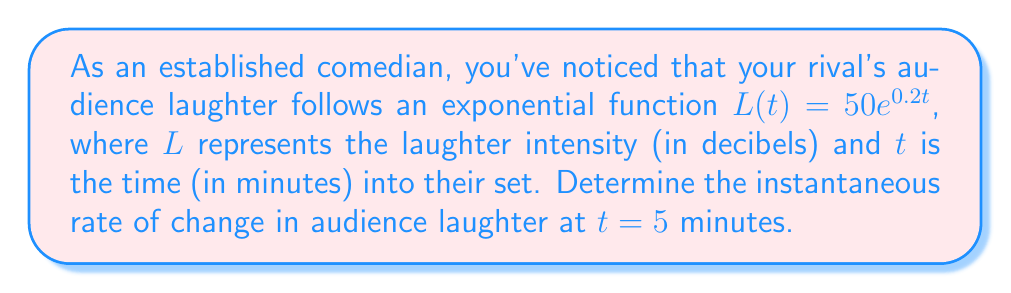Help me with this question. To find the instantaneous rate of change, we need to calculate the derivative of the given function and evaluate it at $t = 5$.

1) The given function is $L(t) = 50e^{0.2t}$

2) To find the derivative, we use the chain rule:
   $L'(t) = 50 \cdot 0.2 \cdot e^{0.2t} = 10e^{0.2t}$

3) Now, we evaluate $L'(t)$ at $t = 5$:
   $L'(5) = 10e^{0.2(5)} = 10e^1 = 10e \approx 27.18$

4) The units for this rate of change are decibels per minute (dB/min).

Therefore, at 5 minutes into the set, the rival's audience laughter is increasing at a rate of approximately 27.18 dB/min.
Answer: $27.18$ dB/min 